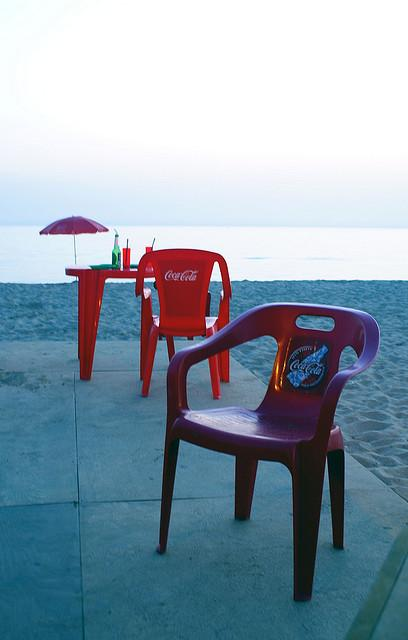What drink brand is seen on the chairs?

Choices:
A) coca cola
B) pepsi
C) sprite
D) canada dry coca cola 